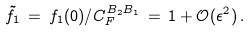Convert formula to latex. <formula><loc_0><loc_0><loc_500><loc_500>\tilde { f } _ { 1 } \, = \, f _ { 1 } ( 0 ) / C _ { F } ^ { B _ { 2 } B _ { 1 } } \, = \, 1 + \mathcal { O } ( \epsilon ^ { 2 } ) \, .</formula> 